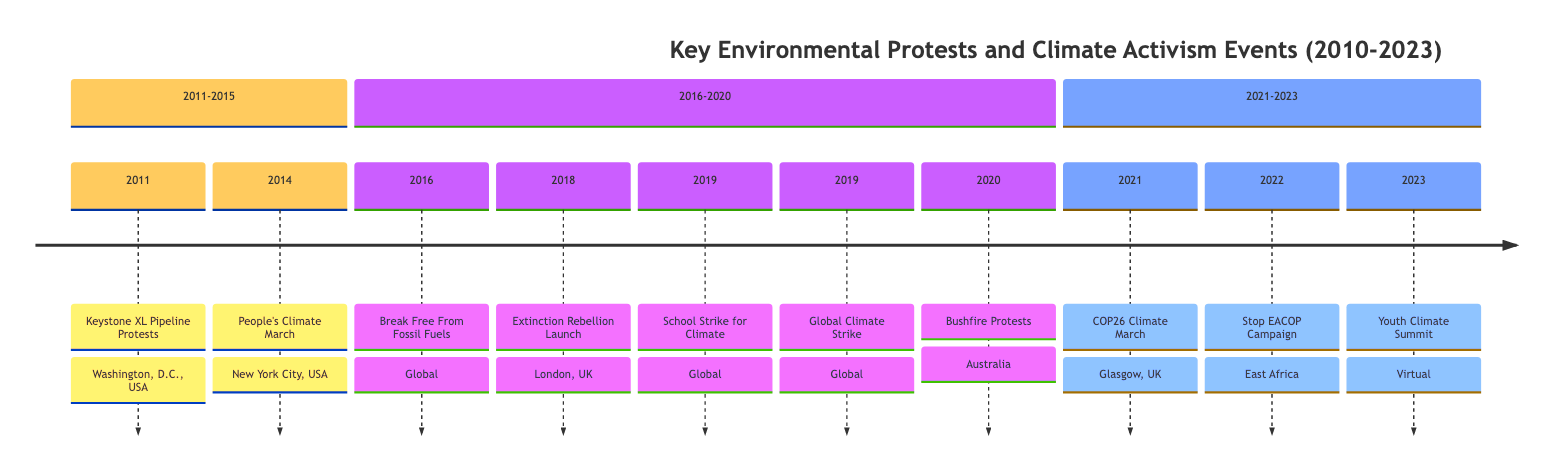What was the first event listed in the timeline? The timeline starts with the Keystone XL Pipeline Protests. This event is placed first in the section labeled "2011-2015."
Answer: Keystone XL Pipeline Protests How many major events are marked in the year 2019? The timeline lists two significant events for the year 2019: the School Strike for Climate and the Global Climate Strike. They are both in the section for 2016-2020.
Answer: 2 Which location hosted the People's Climate March? The People's Climate March took place in New York City, as indicated in the timeline.
Answer: New York City, USA What significant protest occurred in London in 2018? The timeline specifies that Extinction Rebellion was officially launched in London during 2018, marking a notable event.
Answer: Extinction Rebellion Launch Which event took place in 2022 and focused on East Africa? The Stop EACOP Campaign is the event that occurred in 2022 regarding environmental issues in East Africa, highlighted in the timeline.
Answer: Stop EACOP Campaign Which event had a virtual gathering in 2023? The Youth Climate Summit, as mentioned in the timeline, was conducted virtually, marking it as a key event for that year.
Answer: Youth Climate Summit Choose the last event on the timeline and provide its date. The last event listed is the Youth Climate Summit, which took place in April 2023. This information is easily identifiable at the end of the final section of the diagram.
Answer: 2023-04 What global movement inspired the School Strike for Climate? The School Strike for Climate was inspired by Greta Thunberg, which the timeline notes in the description for this event.
Answer: Greta Thunberg Which event was part of a series of protests against fossil fuels in 2016? The event named Break Free From Fossil Fuels organized in 2016 fits this description. It was part of global efforts to protest against fossil fuel usage.
Answer: Break Free From Fossil Fuels 